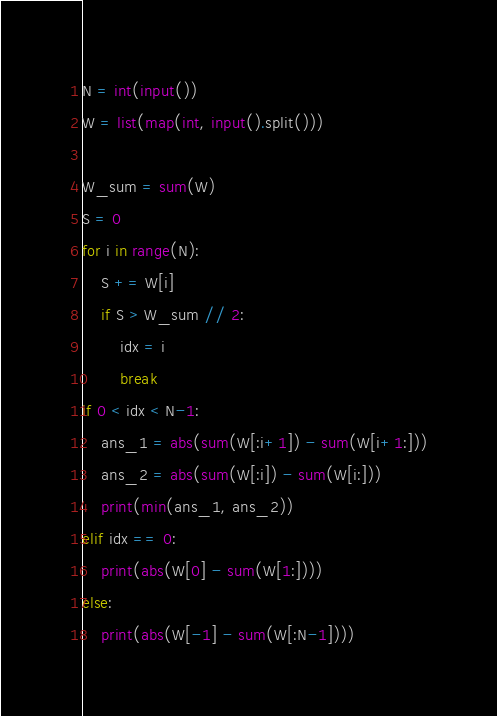Convert code to text. <code><loc_0><loc_0><loc_500><loc_500><_Python_>N = int(input())
W = list(map(int, input().split()))

W_sum = sum(W)
S = 0
for i in range(N):
    S += W[i]
    if S > W_sum // 2:
        idx = i
        break
if 0 < idx < N-1:
    ans_1 = abs(sum(W[:i+1]) - sum(W[i+1:]))
    ans_2 = abs(sum(W[:i]) - sum(W[i:]))
    print(min(ans_1, ans_2))
elif idx == 0:
    print(abs(W[0] - sum(W[1:])))
else:
    print(abs(W[-1] - sum(W[:N-1])))</code> 